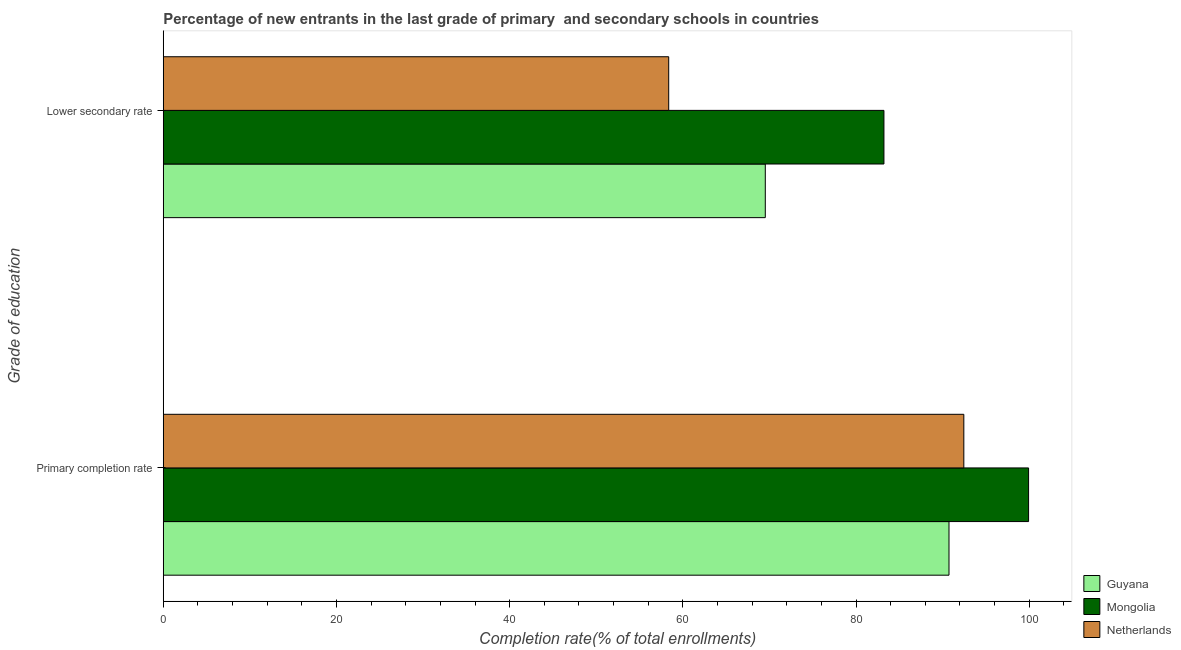How many different coloured bars are there?
Ensure brevity in your answer.  3. Are the number of bars per tick equal to the number of legend labels?
Offer a very short reply. Yes. How many bars are there on the 1st tick from the bottom?
Keep it short and to the point. 3. What is the label of the 1st group of bars from the top?
Ensure brevity in your answer.  Lower secondary rate. What is the completion rate in primary schools in Mongolia?
Provide a succinct answer. 99.92. Across all countries, what is the maximum completion rate in primary schools?
Make the answer very short. 99.92. Across all countries, what is the minimum completion rate in primary schools?
Your answer should be compact. 90.73. In which country was the completion rate in secondary schools maximum?
Offer a very short reply. Mongolia. In which country was the completion rate in primary schools minimum?
Your response must be concise. Guyana. What is the total completion rate in primary schools in the graph?
Keep it short and to the point. 283.11. What is the difference between the completion rate in secondary schools in Netherlands and that in Guyana?
Offer a terse response. -11.15. What is the difference between the completion rate in secondary schools in Guyana and the completion rate in primary schools in Netherlands?
Make the answer very short. -22.93. What is the average completion rate in primary schools per country?
Provide a succinct answer. 94.37. What is the difference between the completion rate in primary schools and completion rate in secondary schools in Guyana?
Ensure brevity in your answer.  21.21. What is the ratio of the completion rate in primary schools in Netherlands to that in Mongolia?
Make the answer very short. 0.93. What does the 3rd bar from the top in Lower secondary rate represents?
Provide a succinct answer. Guyana. What does the 2nd bar from the bottom in Primary completion rate represents?
Keep it short and to the point. Mongolia. How many bars are there?
Provide a succinct answer. 6. Are all the bars in the graph horizontal?
Offer a very short reply. Yes. How many countries are there in the graph?
Offer a terse response. 3. Are the values on the major ticks of X-axis written in scientific E-notation?
Provide a short and direct response. No. Does the graph contain any zero values?
Your response must be concise. No. Does the graph contain grids?
Your response must be concise. No. Where does the legend appear in the graph?
Make the answer very short. Bottom right. How many legend labels are there?
Offer a terse response. 3. What is the title of the graph?
Your response must be concise. Percentage of new entrants in the last grade of primary  and secondary schools in countries. Does "Morocco" appear as one of the legend labels in the graph?
Give a very brief answer. No. What is the label or title of the X-axis?
Your answer should be compact. Completion rate(% of total enrollments). What is the label or title of the Y-axis?
Your response must be concise. Grade of education. What is the Completion rate(% of total enrollments) of Guyana in Primary completion rate?
Provide a short and direct response. 90.73. What is the Completion rate(% of total enrollments) of Mongolia in Primary completion rate?
Offer a terse response. 99.92. What is the Completion rate(% of total enrollments) in Netherlands in Primary completion rate?
Your response must be concise. 92.45. What is the Completion rate(% of total enrollments) in Guyana in Lower secondary rate?
Provide a succinct answer. 69.52. What is the Completion rate(% of total enrollments) of Mongolia in Lower secondary rate?
Offer a terse response. 83.22. What is the Completion rate(% of total enrollments) of Netherlands in Lower secondary rate?
Ensure brevity in your answer.  58.37. Across all Grade of education, what is the maximum Completion rate(% of total enrollments) in Guyana?
Your answer should be very brief. 90.73. Across all Grade of education, what is the maximum Completion rate(% of total enrollments) in Mongolia?
Make the answer very short. 99.92. Across all Grade of education, what is the maximum Completion rate(% of total enrollments) of Netherlands?
Provide a short and direct response. 92.45. Across all Grade of education, what is the minimum Completion rate(% of total enrollments) of Guyana?
Keep it short and to the point. 69.52. Across all Grade of education, what is the minimum Completion rate(% of total enrollments) of Mongolia?
Ensure brevity in your answer.  83.22. Across all Grade of education, what is the minimum Completion rate(% of total enrollments) in Netherlands?
Ensure brevity in your answer.  58.37. What is the total Completion rate(% of total enrollments) of Guyana in the graph?
Provide a succinct answer. 160.26. What is the total Completion rate(% of total enrollments) in Mongolia in the graph?
Offer a very short reply. 183.15. What is the total Completion rate(% of total enrollments) in Netherlands in the graph?
Your answer should be compact. 150.81. What is the difference between the Completion rate(% of total enrollments) in Guyana in Primary completion rate and that in Lower secondary rate?
Provide a short and direct response. 21.21. What is the difference between the Completion rate(% of total enrollments) in Mongolia in Primary completion rate and that in Lower secondary rate?
Your response must be concise. 16.7. What is the difference between the Completion rate(% of total enrollments) in Netherlands in Primary completion rate and that in Lower secondary rate?
Keep it short and to the point. 34.08. What is the difference between the Completion rate(% of total enrollments) of Guyana in Primary completion rate and the Completion rate(% of total enrollments) of Mongolia in Lower secondary rate?
Your answer should be compact. 7.51. What is the difference between the Completion rate(% of total enrollments) in Guyana in Primary completion rate and the Completion rate(% of total enrollments) in Netherlands in Lower secondary rate?
Keep it short and to the point. 32.37. What is the difference between the Completion rate(% of total enrollments) of Mongolia in Primary completion rate and the Completion rate(% of total enrollments) of Netherlands in Lower secondary rate?
Ensure brevity in your answer.  41.56. What is the average Completion rate(% of total enrollments) in Guyana per Grade of education?
Give a very brief answer. 80.13. What is the average Completion rate(% of total enrollments) in Mongolia per Grade of education?
Offer a terse response. 91.57. What is the average Completion rate(% of total enrollments) in Netherlands per Grade of education?
Make the answer very short. 75.41. What is the difference between the Completion rate(% of total enrollments) in Guyana and Completion rate(% of total enrollments) in Mongolia in Primary completion rate?
Provide a short and direct response. -9.19. What is the difference between the Completion rate(% of total enrollments) of Guyana and Completion rate(% of total enrollments) of Netherlands in Primary completion rate?
Make the answer very short. -1.71. What is the difference between the Completion rate(% of total enrollments) of Mongolia and Completion rate(% of total enrollments) of Netherlands in Primary completion rate?
Offer a terse response. 7.48. What is the difference between the Completion rate(% of total enrollments) in Guyana and Completion rate(% of total enrollments) in Mongolia in Lower secondary rate?
Ensure brevity in your answer.  -13.7. What is the difference between the Completion rate(% of total enrollments) of Guyana and Completion rate(% of total enrollments) of Netherlands in Lower secondary rate?
Provide a short and direct response. 11.15. What is the difference between the Completion rate(% of total enrollments) in Mongolia and Completion rate(% of total enrollments) in Netherlands in Lower secondary rate?
Your response must be concise. 24.86. What is the ratio of the Completion rate(% of total enrollments) of Guyana in Primary completion rate to that in Lower secondary rate?
Give a very brief answer. 1.31. What is the ratio of the Completion rate(% of total enrollments) in Mongolia in Primary completion rate to that in Lower secondary rate?
Give a very brief answer. 1.2. What is the ratio of the Completion rate(% of total enrollments) in Netherlands in Primary completion rate to that in Lower secondary rate?
Keep it short and to the point. 1.58. What is the difference between the highest and the second highest Completion rate(% of total enrollments) of Guyana?
Offer a terse response. 21.21. What is the difference between the highest and the second highest Completion rate(% of total enrollments) of Mongolia?
Make the answer very short. 16.7. What is the difference between the highest and the second highest Completion rate(% of total enrollments) of Netherlands?
Offer a very short reply. 34.08. What is the difference between the highest and the lowest Completion rate(% of total enrollments) of Guyana?
Offer a very short reply. 21.21. What is the difference between the highest and the lowest Completion rate(% of total enrollments) in Mongolia?
Give a very brief answer. 16.7. What is the difference between the highest and the lowest Completion rate(% of total enrollments) in Netherlands?
Ensure brevity in your answer.  34.08. 